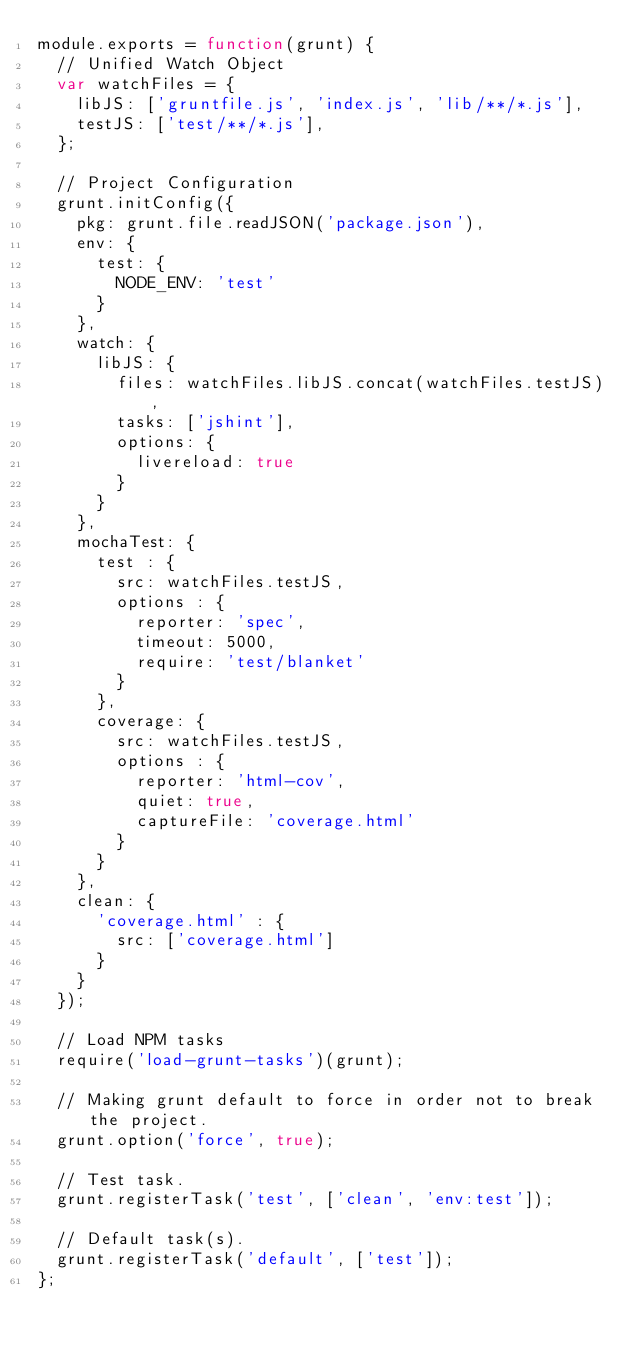<code> <loc_0><loc_0><loc_500><loc_500><_JavaScript_>module.exports = function(grunt) {
	// Unified Watch Object
	var watchFiles = {
		libJS: ['gruntfile.js', 'index.js', 'lib/**/*.js'],
		testJS: ['test/**/*.js'],
	};

	// Project Configuration
	grunt.initConfig({
		pkg: grunt.file.readJSON('package.json'),
		env: {
			test: {
				NODE_ENV: 'test'
			}
		},
		watch: {
			libJS: {
				files: watchFiles.libJS.concat(watchFiles.testJS),
				tasks: ['jshint'],
				options: {
					livereload: true
				}
			}
		},
		mochaTest: {
			test : {
				src: watchFiles.testJS,
				options : {
					reporter: 'spec',
					timeout: 5000,
					require: 'test/blanket'
				}
			},
			coverage: {
				src: watchFiles.testJS,
				options : {
					reporter: 'html-cov',
					quiet: true,
					captureFile: 'coverage.html'
				}
			}
		},
		clean: {
			'coverage.html' : {
				src: ['coverage.html']
			}
		}
	});

	// Load NPM tasks
	require('load-grunt-tasks')(grunt);

	// Making grunt default to force in order not to break the project.
	grunt.option('force', true);

	// Test task.
	grunt.registerTask('test', ['clean', 'env:test']);

	// Default task(s).
	grunt.registerTask('default', ['test']);
};</code> 